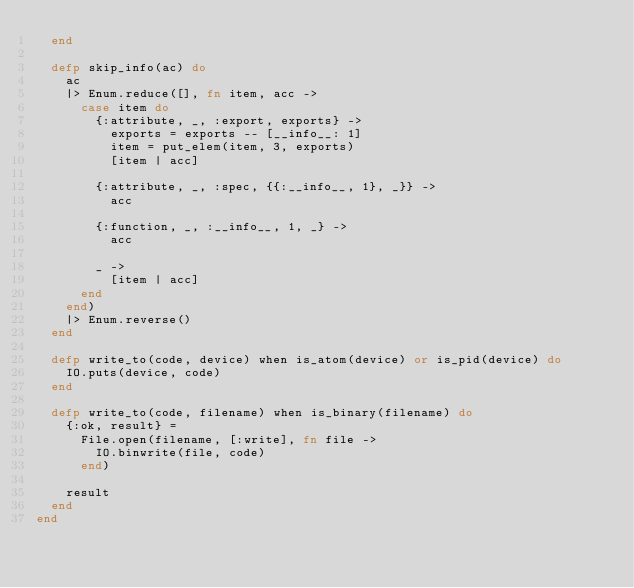Convert code to text. <code><loc_0><loc_0><loc_500><loc_500><_Elixir_>  end

  defp skip_info(ac) do
    ac
    |> Enum.reduce([], fn item, acc ->
      case item do
        {:attribute, _, :export, exports} ->
          exports = exports -- [__info__: 1]
          item = put_elem(item, 3, exports)
          [item | acc]

        {:attribute, _, :spec, {{:__info__, 1}, _}} ->
          acc

        {:function, _, :__info__, 1, _} ->
          acc

        _ ->
          [item | acc]
      end
    end)
    |> Enum.reverse()
  end

  defp write_to(code, device) when is_atom(device) or is_pid(device) do
    IO.puts(device, code)
  end

  defp write_to(code, filename) when is_binary(filename) do
    {:ok, result} =
      File.open(filename, [:write], fn file ->
        IO.binwrite(file, code)
      end)

    result
  end
end
</code> 